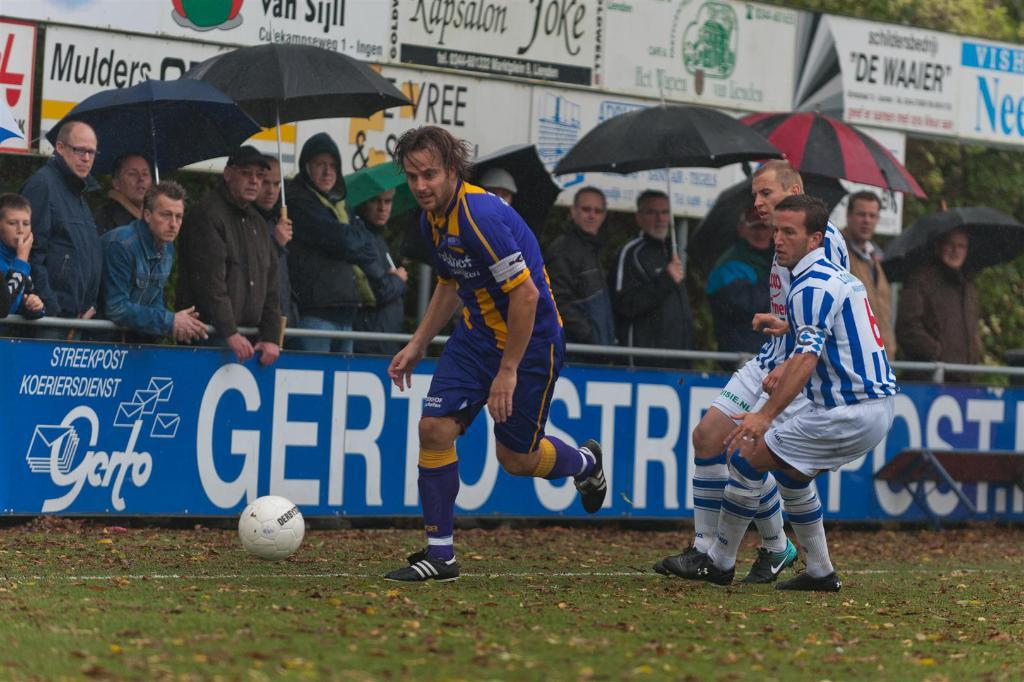Provide a one-sentence caption for the provided image. Fans watch a soccer match in progress sponsored by Gerto. 